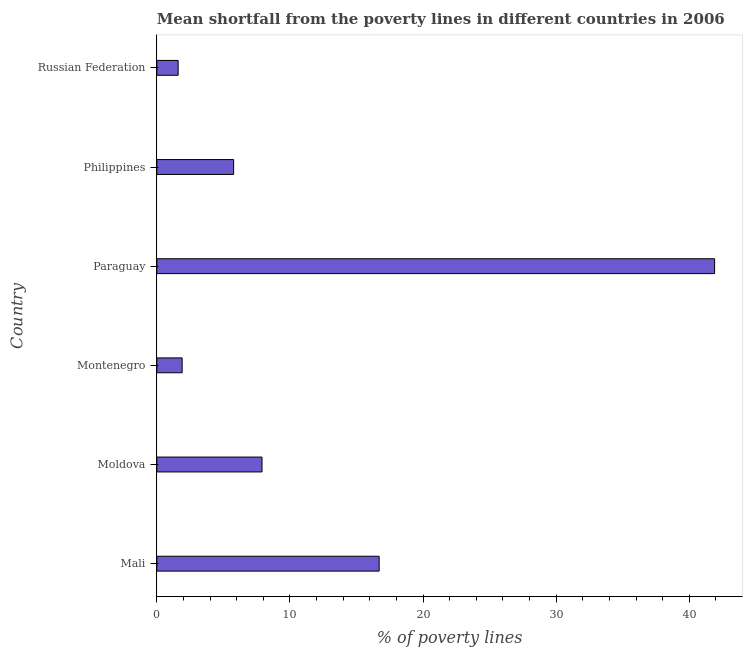Does the graph contain any zero values?
Provide a succinct answer. No. Does the graph contain grids?
Make the answer very short. No. What is the title of the graph?
Offer a very short reply. Mean shortfall from the poverty lines in different countries in 2006. What is the label or title of the X-axis?
Your response must be concise. % of poverty lines. What is the label or title of the Y-axis?
Keep it short and to the point. Country. What is the poverty gap at national poverty lines in Philippines?
Provide a short and direct response. 5.77. Across all countries, what is the maximum poverty gap at national poverty lines?
Your response must be concise. 41.9. In which country was the poverty gap at national poverty lines maximum?
Provide a succinct answer. Paraguay. In which country was the poverty gap at national poverty lines minimum?
Your response must be concise. Russian Federation. What is the sum of the poverty gap at national poverty lines?
Your answer should be compact. 75.77. What is the difference between the poverty gap at national poverty lines in Mali and Russian Federation?
Your answer should be very brief. 15.1. What is the average poverty gap at national poverty lines per country?
Keep it short and to the point. 12.63. What is the median poverty gap at national poverty lines?
Offer a very short reply. 6.83. In how many countries, is the poverty gap at national poverty lines greater than 10 %?
Give a very brief answer. 2. What is the ratio of the poverty gap at national poverty lines in Mali to that in Moldova?
Your answer should be compact. 2.11. Is the poverty gap at national poverty lines in Montenegro less than that in Philippines?
Provide a succinct answer. Yes. Is the difference between the poverty gap at national poverty lines in Montenegro and Russian Federation greater than the difference between any two countries?
Offer a terse response. No. What is the difference between the highest and the second highest poverty gap at national poverty lines?
Make the answer very short. 25.2. Is the sum of the poverty gap at national poverty lines in Moldova and Russian Federation greater than the maximum poverty gap at national poverty lines across all countries?
Offer a very short reply. No. What is the difference between the highest and the lowest poverty gap at national poverty lines?
Provide a succinct answer. 40.3. Are all the bars in the graph horizontal?
Keep it short and to the point. Yes. How many countries are there in the graph?
Ensure brevity in your answer.  6. What is the % of poverty lines of Moldova?
Offer a very short reply. 7.9. What is the % of poverty lines of Paraguay?
Provide a succinct answer. 41.9. What is the % of poverty lines of Philippines?
Your answer should be very brief. 5.77. What is the difference between the % of poverty lines in Mali and Moldova?
Make the answer very short. 8.8. What is the difference between the % of poverty lines in Mali and Montenegro?
Keep it short and to the point. 14.8. What is the difference between the % of poverty lines in Mali and Paraguay?
Give a very brief answer. -25.2. What is the difference between the % of poverty lines in Mali and Philippines?
Make the answer very short. 10.93. What is the difference between the % of poverty lines in Moldova and Montenegro?
Make the answer very short. 6. What is the difference between the % of poverty lines in Moldova and Paraguay?
Your answer should be very brief. -34. What is the difference between the % of poverty lines in Moldova and Philippines?
Make the answer very short. 2.13. What is the difference between the % of poverty lines in Montenegro and Philippines?
Your response must be concise. -3.87. What is the difference between the % of poverty lines in Montenegro and Russian Federation?
Ensure brevity in your answer.  0.3. What is the difference between the % of poverty lines in Paraguay and Philippines?
Offer a terse response. 36.13. What is the difference between the % of poverty lines in Paraguay and Russian Federation?
Give a very brief answer. 40.3. What is the difference between the % of poverty lines in Philippines and Russian Federation?
Offer a terse response. 4.17. What is the ratio of the % of poverty lines in Mali to that in Moldova?
Make the answer very short. 2.11. What is the ratio of the % of poverty lines in Mali to that in Montenegro?
Your answer should be compact. 8.79. What is the ratio of the % of poverty lines in Mali to that in Paraguay?
Offer a very short reply. 0.4. What is the ratio of the % of poverty lines in Mali to that in Philippines?
Make the answer very short. 2.9. What is the ratio of the % of poverty lines in Mali to that in Russian Federation?
Your answer should be very brief. 10.44. What is the ratio of the % of poverty lines in Moldova to that in Montenegro?
Offer a very short reply. 4.16. What is the ratio of the % of poverty lines in Moldova to that in Paraguay?
Provide a short and direct response. 0.19. What is the ratio of the % of poverty lines in Moldova to that in Philippines?
Your answer should be very brief. 1.37. What is the ratio of the % of poverty lines in Moldova to that in Russian Federation?
Give a very brief answer. 4.94. What is the ratio of the % of poverty lines in Montenegro to that in Paraguay?
Your answer should be compact. 0.04. What is the ratio of the % of poverty lines in Montenegro to that in Philippines?
Keep it short and to the point. 0.33. What is the ratio of the % of poverty lines in Montenegro to that in Russian Federation?
Your answer should be compact. 1.19. What is the ratio of the % of poverty lines in Paraguay to that in Philippines?
Offer a very short reply. 7.26. What is the ratio of the % of poverty lines in Paraguay to that in Russian Federation?
Keep it short and to the point. 26.19. What is the ratio of the % of poverty lines in Philippines to that in Russian Federation?
Make the answer very short. 3.6. 